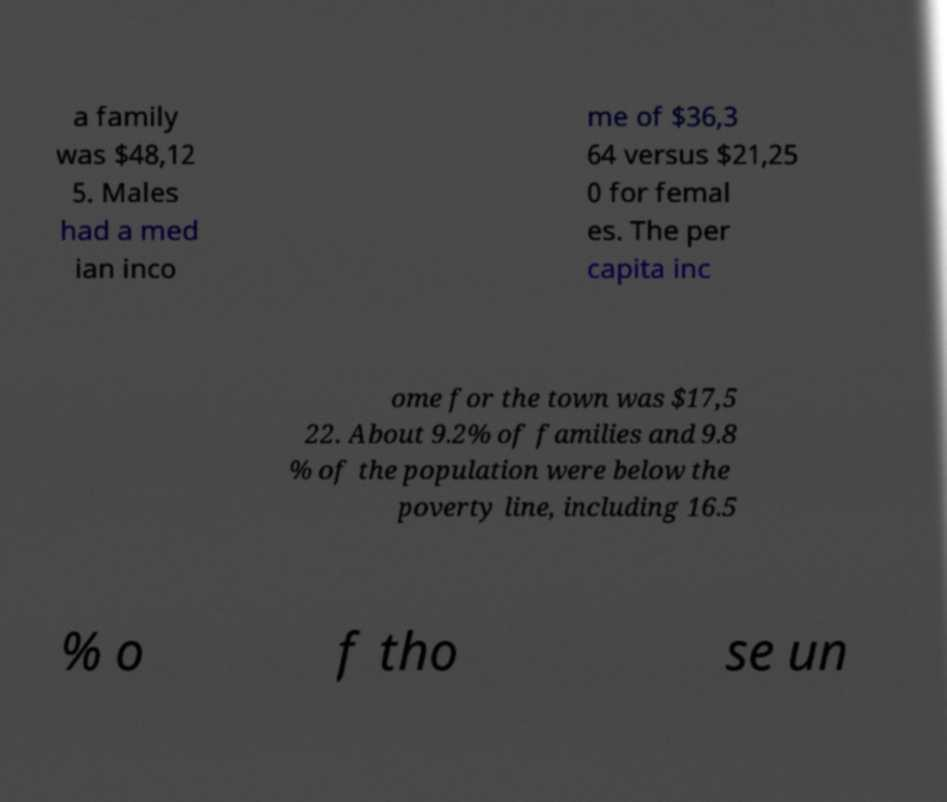Can you read and provide the text displayed in the image?This photo seems to have some interesting text. Can you extract and type it out for me? a family was $48,12 5. Males had a med ian inco me of $36,3 64 versus $21,25 0 for femal es. The per capita inc ome for the town was $17,5 22. About 9.2% of families and 9.8 % of the population were below the poverty line, including 16.5 % o f tho se un 